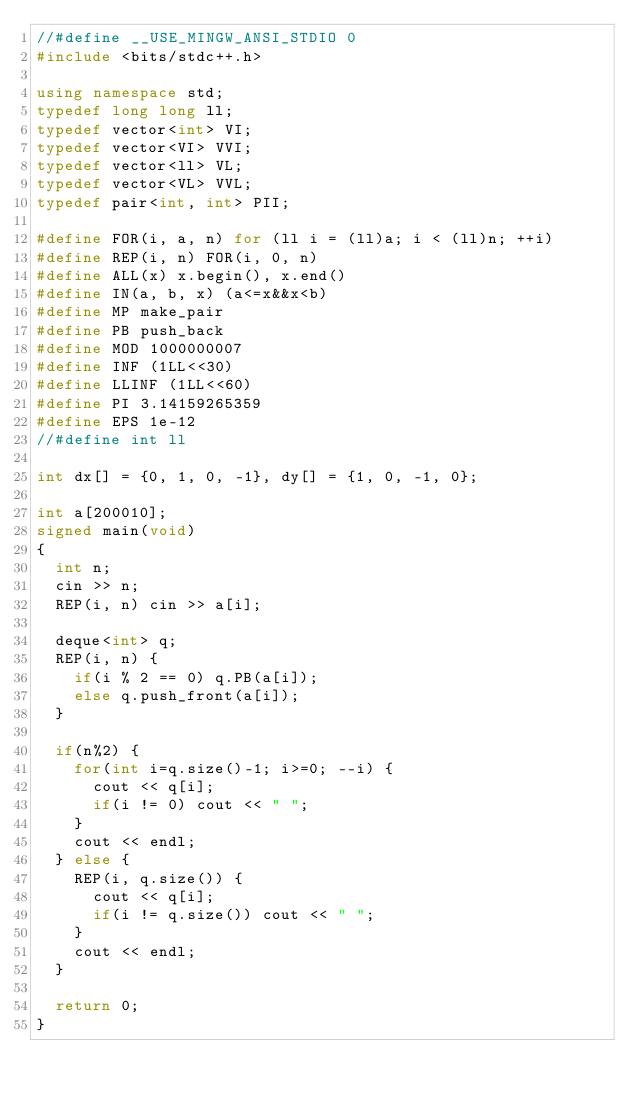<code> <loc_0><loc_0><loc_500><loc_500><_C++_>//#define __USE_MINGW_ANSI_STDIO 0
#include <bits/stdc++.h>

using namespace std;
typedef long long ll;
typedef vector<int> VI;
typedef vector<VI> VVI;
typedef vector<ll> VL;
typedef vector<VL> VVL;
typedef pair<int, int> PII;

#define FOR(i, a, n) for (ll i = (ll)a; i < (ll)n; ++i)
#define REP(i, n) FOR(i, 0, n)
#define ALL(x) x.begin(), x.end()
#define IN(a, b, x) (a<=x&&x<b)
#define MP make_pair
#define PB push_back
#define MOD 1000000007
#define INF (1LL<<30)
#define LLINF (1LL<<60)
#define PI 3.14159265359
#define EPS 1e-12
//#define int ll

int dx[] = {0, 1, 0, -1}, dy[] = {1, 0, -1, 0};

int a[200010];
signed main(void)
{
  int n;
  cin >> n;
  REP(i, n) cin >> a[i];

  deque<int> q;
  REP(i, n) {
    if(i % 2 == 0) q.PB(a[i]);
    else q.push_front(a[i]);
  }

  if(n%2) {
    for(int i=q.size()-1; i>=0; --i) {
      cout << q[i];
      if(i != 0) cout << " ";
    }
    cout << endl;
  } else {
    REP(i, q.size()) {
      cout << q[i];
      if(i != q.size()) cout << " ";
    }
    cout << endl;
  }

  return 0;
}
</code> 